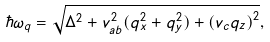<formula> <loc_0><loc_0><loc_500><loc_500>\hbar { \omega } _ { q } = \sqrt { \Delta ^ { 2 } + v _ { a b } ^ { 2 } ( q _ { x } ^ { 2 } + q _ { y } ^ { 2 } ) + \left ( v _ { c } q _ { z } \right ) ^ { 2 } } ,</formula> 